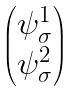Convert formula to latex. <formula><loc_0><loc_0><loc_500><loc_500>\begin{pmatrix} \psi ^ { 1 } _ { \sigma } \\ \psi ^ { 2 } _ { \sigma } \end{pmatrix}</formula> 